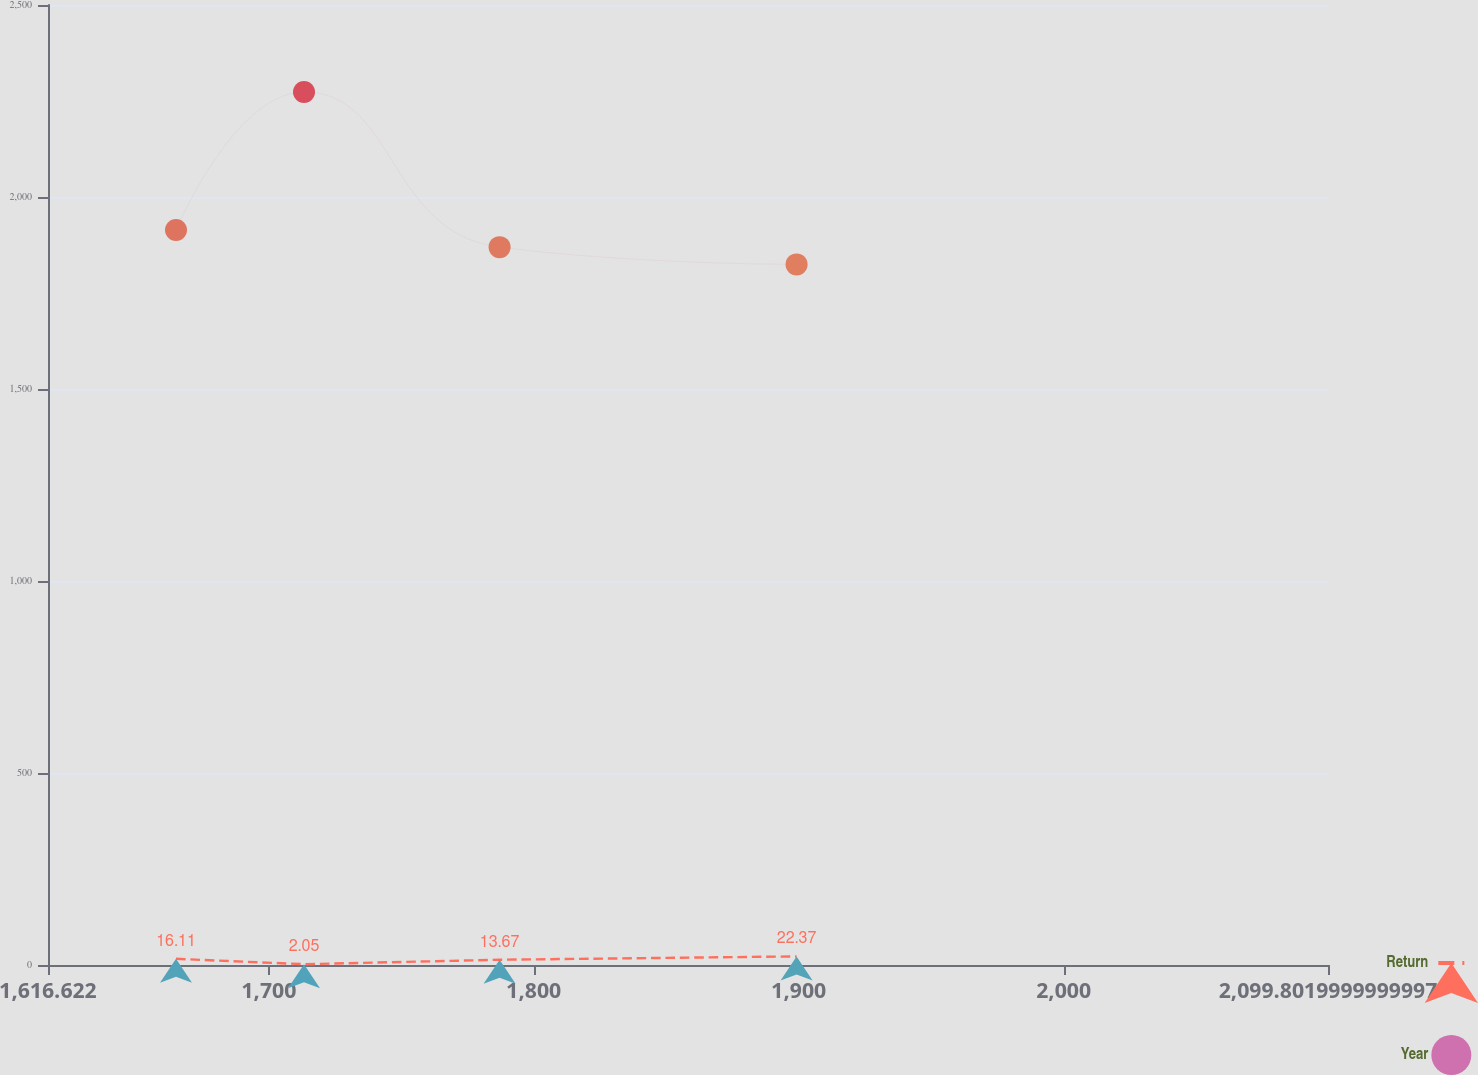Convert chart. <chart><loc_0><loc_0><loc_500><loc_500><line_chart><ecel><fcel>Return<fcel>Year<nl><fcel>1664.94<fcel>16.11<fcel>1914.3<nl><fcel>1713.26<fcel>2.05<fcel>2273.33<nl><fcel>1787.09<fcel>13.67<fcel>1869.42<nl><fcel>1899.2<fcel>22.37<fcel>1824.54<nl><fcel>2148.12<fcel>24.6<fcel>2159.41<nl></chart> 